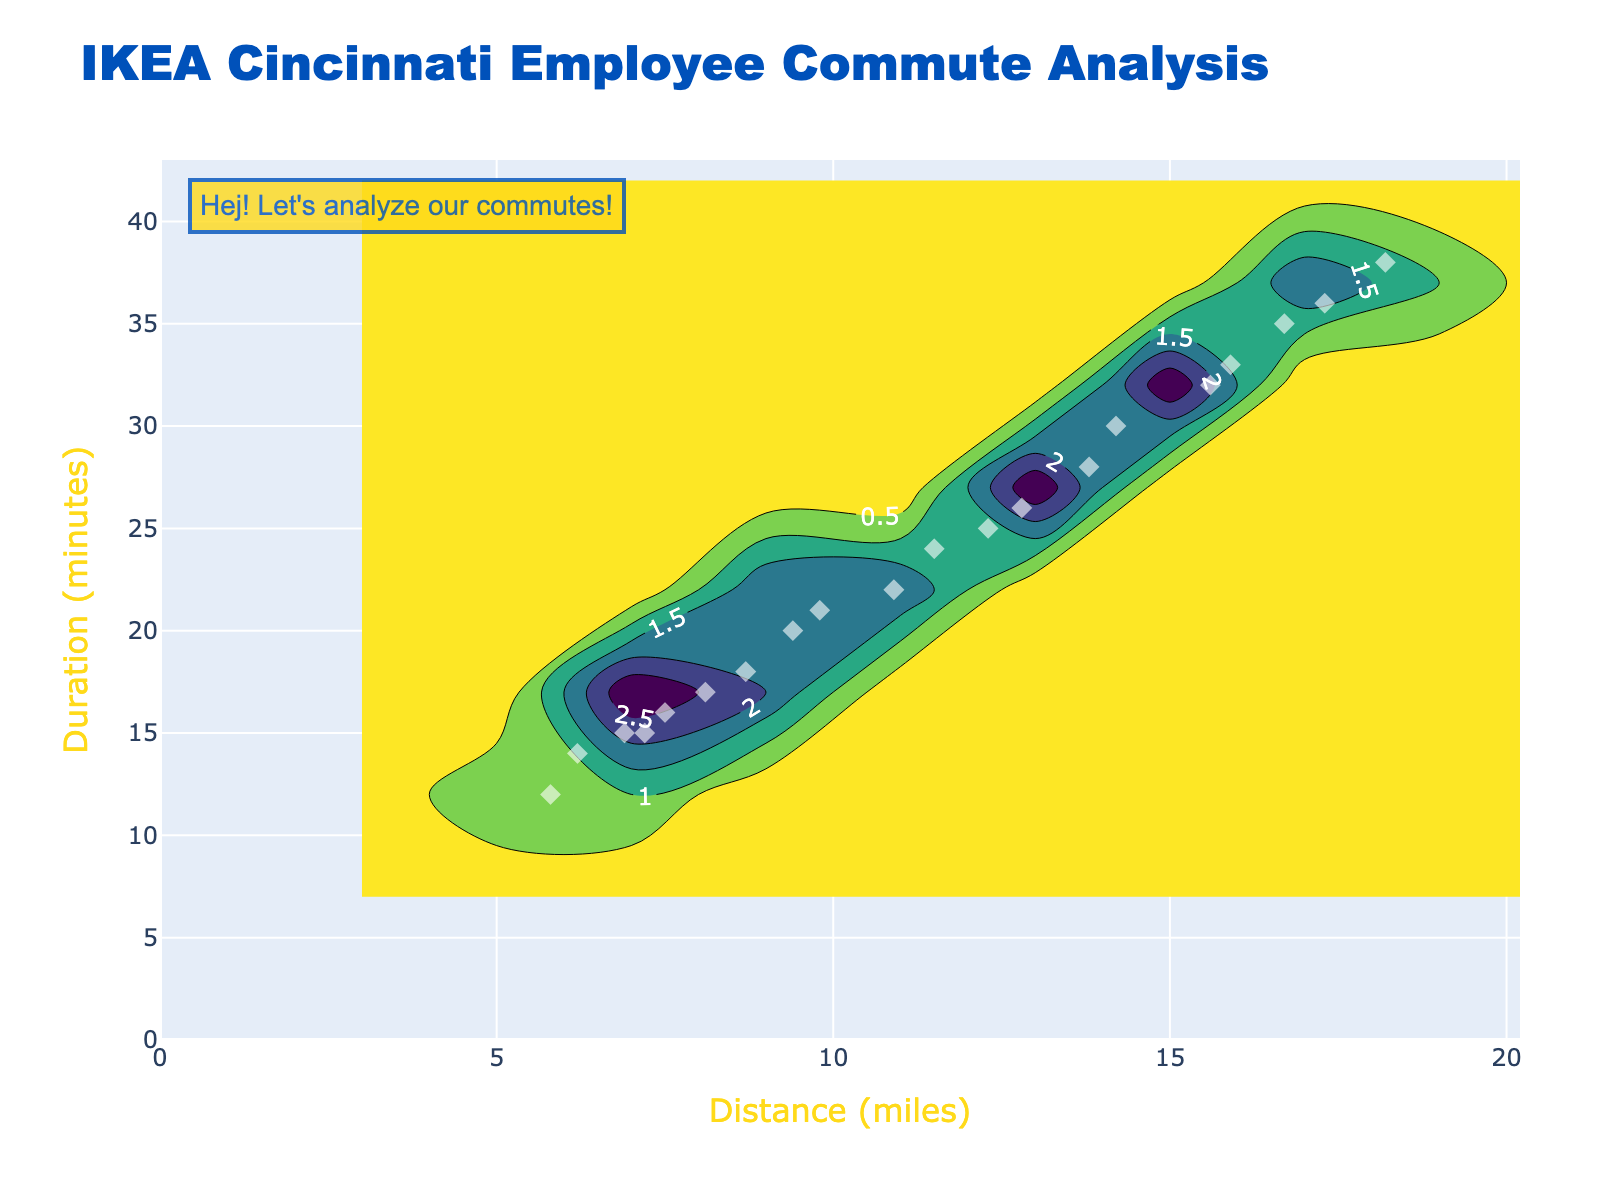How many data points are shown in the plot? Count the number of individual markers representing employees in the figure.
Answer: 20 What is the title of the plot? Read the text at the top of the plot to identify the title.
Answer: IKEA Cincinnati Employee Commute Analysis What is the range of the x-axis? Observe the minimum and maximum distance values displayed along the x-axis.
Answer: 0 to 20 Which employee has the longest commute time? Hover over or identify the marker at the top of the y-axis and find the associated employee name.
Answer: Chris Anderson Approximately, how far does Lisa Martinez commute to work? Hover over or identify the marker associated with Lisa Martinez and read the distance value on the x-axis.
Answer: 7.5 miles What are the x and y-axis titles of the plot? Observe the titles below the x-axis and beside the y-axis.
Answer: Distance (miles) and Duration (minutes) What is the color scheme of the hexbin plot? Identify the colors used in the density representation of the plot.
Answer: Viridis Which employee's commute duration is closest to the average commute duration? Calculate the average duration from the data and identify the closest marker to this value. The average is obtained by summing up all durations and dividing by the number of data points: (25+18+32+14+22+38+16+28+20+35+12+24+30+17+36+15+26+21+33+15)/20 ≈ 23.45.
Answer: Laura Nguyen (26 minutes) Which employees have the shortest commute distance and how long is it? Identify the marker with the smallest x-axis value and find the associated employee name and duration.
Answer: Jessica Lee, 5.8 miles How does the commute distance generally relate to commute duration in the figure? Observe the trend of how commute duration changes with increasing distance.
Answer: Longer distances generally correlate with longer durations 